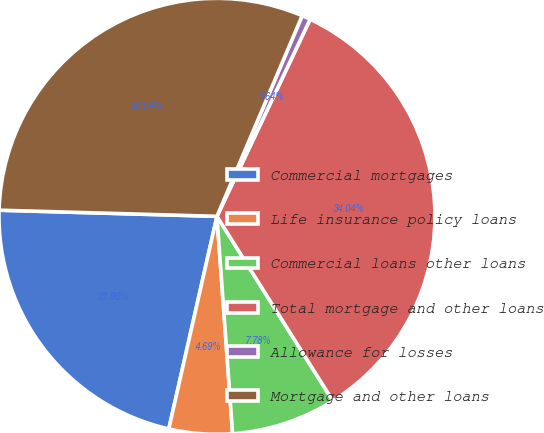<chart> <loc_0><loc_0><loc_500><loc_500><pie_chart><fcel>Commercial mortgages<fcel>Life insurance policy loans<fcel>Commercial loans other loans<fcel>Total mortgage and other loans<fcel>Allowance for losses<fcel>Mortgage and other loans<nl><fcel>21.9%<fcel>4.69%<fcel>7.78%<fcel>34.04%<fcel>0.64%<fcel>30.94%<nl></chart> 